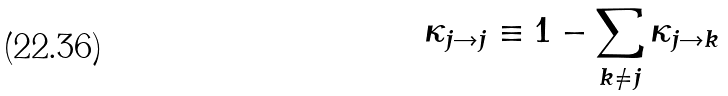<formula> <loc_0><loc_0><loc_500><loc_500>\kappa _ { j \rightarrow j } \equiv 1 - \sum _ { k \neq j } \kappa _ { j \rightarrow k }</formula> 